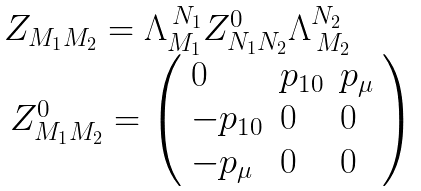<formula> <loc_0><loc_0><loc_500><loc_500>\begin{array} { l } Z _ { M _ { 1 } M _ { 2 } } = \Lambda _ { M _ { 1 } } ^ { \, N _ { 1 } } Z _ { N _ { 1 } N _ { 2 } } ^ { 0 } \Lambda _ { \, M _ { 2 } } ^ { N _ { 2 } } \\ \, Z _ { M _ { 1 } M _ { 2 } } ^ { 0 } = \left ( \begin{array} { l l l } 0 & p _ { 1 0 } & p _ { \mu } \\ - p _ { 1 0 } & 0 & 0 \\ - p _ { \mu } & 0 & 0 \end{array} \right ) \end{array} \,</formula> 